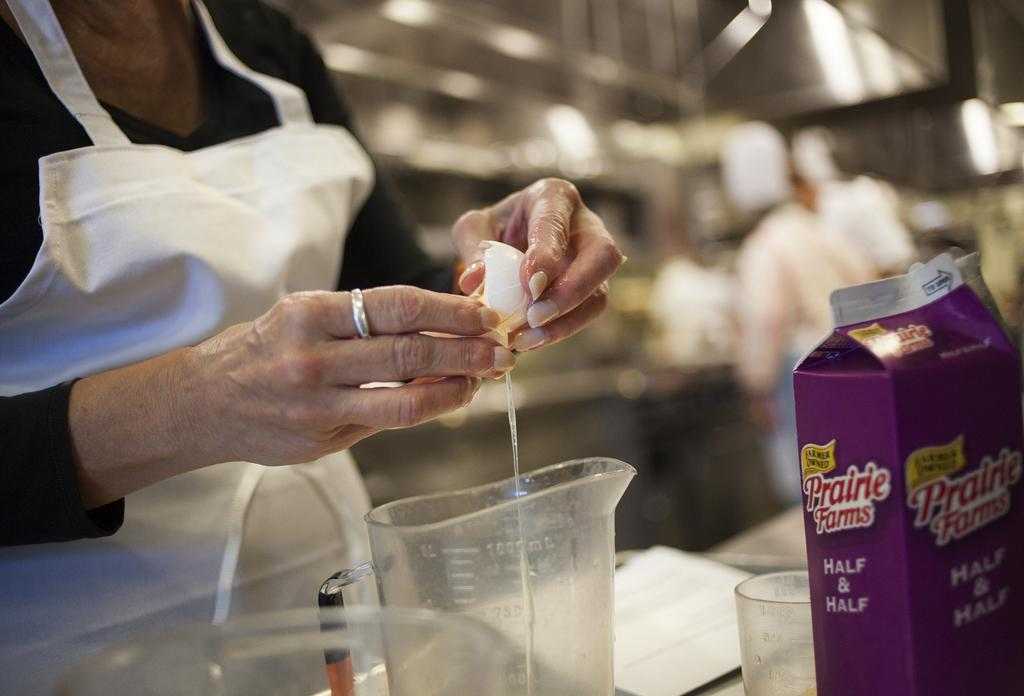<image>
Write a terse but informative summary of the picture. A woman cracking an egg next to a carton of half and half 